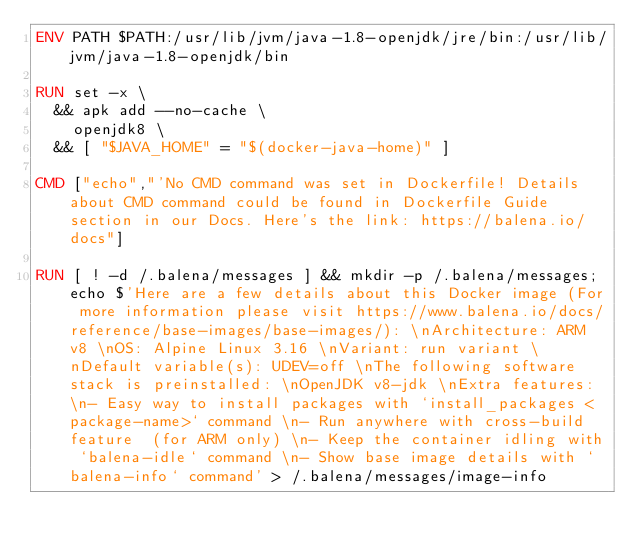Convert code to text. <code><loc_0><loc_0><loc_500><loc_500><_Dockerfile_>ENV PATH $PATH:/usr/lib/jvm/java-1.8-openjdk/jre/bin:/usr/lib/jvm/java-1.8-openjdk/bin

RUN set -x \
	&& apk add --no-cache \
		openjdk8 \
	&& [ "$JAVA_HOME" = "$(docker-java-home)" ]

CMD ["echo","'No CMD command was set in Dockerfile! Details about CMD command could be found in Dockerfile Guide section in our Docs. Here's the link: https://balena.io/docs"]

RUN [ ! -d /.balena/messages ] && mkdir -p /.balena/messages; echo $'Here are a few details about this Docker image (For more information please visit https://www.balena.io/docs/reference/base-images/base-images/): \nArchitecture: ARM v8 \nOS: Alpine Linux 3.16 \nVariant: run variant \nDefault variable(s): UDEV=off \nThe following software stack is preinstalled: \nOpenJDK v8-jdk \nExtra features: \n- Easy way to install packages with `install_packages <package-name>` command \n- Run anywhere with cross-build feature  (for ARM only) \n- Keep the container idling with `balena-idle` command \n- Show base image details with `balena-info` command' > /.balena/messages/image-info</code> 